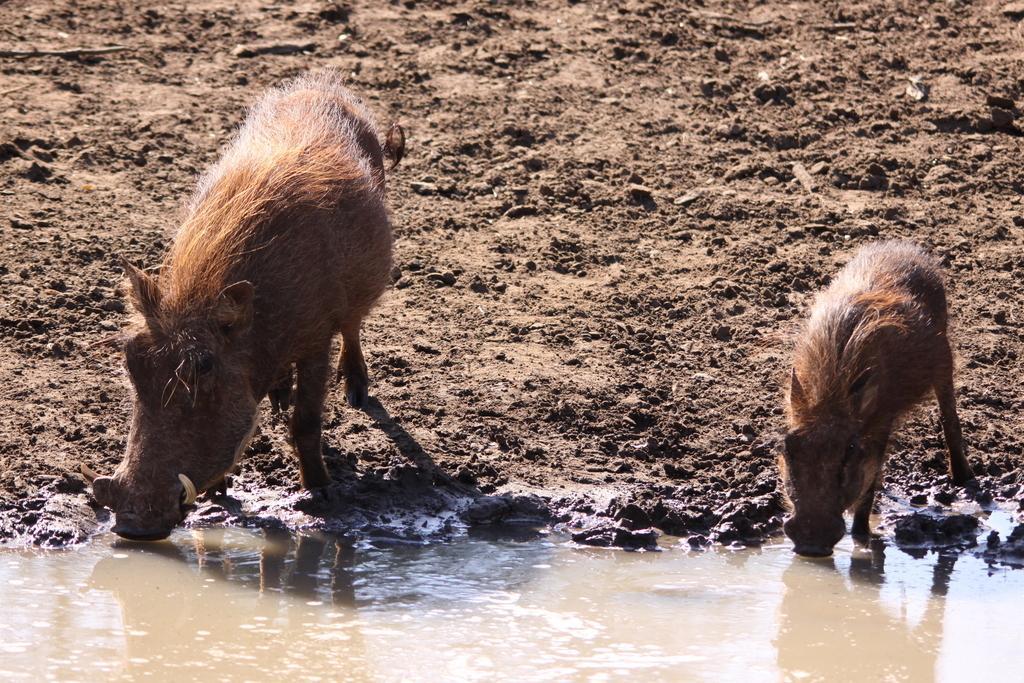Could you give a brief overview of what you see in this image? In this image there are animals. At the bottom there is water. In the background there is soil. 